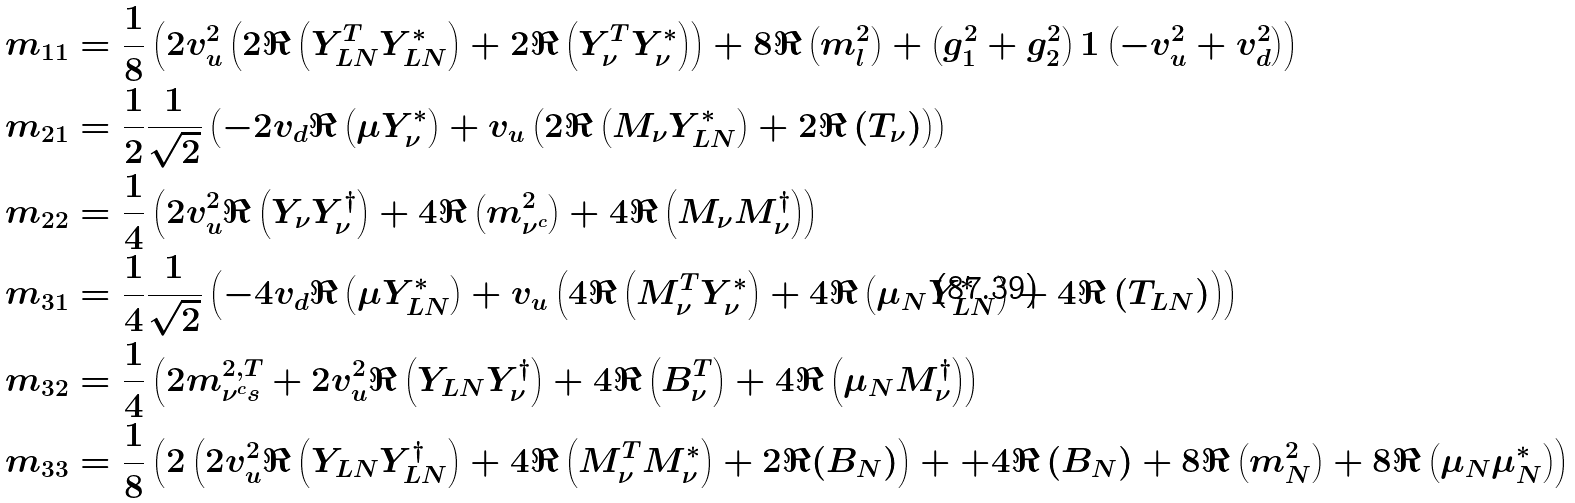<formula> <loc_0><loc_0><loc_500><loc_500>m _ { 1 1 } & = \frac { 1 } { 8 } \left ( 2 v _ { u } ^ { 2 } \left ( 2 { \Re \left ( { Y _ { L N } ^ { T } Y _ { L N } ^ { * } } \right ) } + 2 { \Re \left ( { Y _ { \nu } ^ { T } Y _ { \nu } ^ { * } } \right ) } \right ) + 8 { \Re \left ( m _ { l } ^ { 2 } \right ) } + \left ( g _ { 1 } ^ { 2 } + g _ { 2 } ^ { 2 } \right ) { 1 } \left ( - v _ { u } ^ { 2 } + v _ { d } ^ { 2 } \right ) \right ) \\ m _ { 2 1 } & = \frac { 1 } { 2 } \frac { 1 } { \sqrt { 2 } } \left ( - 2 v _ { d } { \Re \left ( \mu Y _ { \nu } ^ { * } \right ) } + v _ { u } \left ( 2 { \Re \left ( { M _ { \nu } Y _ { L N } ^ { * } } \right ) } + 2 { \Re \left ( T _ { \nu } \right ) } \right ) \right ) \\ m _ { 2 2 } & = \frac { 1 } { 4 } \left ( 2 v _ { u } ^ { 2 } { \Re \left ( { Y _ { \nu } Y _ { \nu } ^ { \dagger } } \right ) } + 4 { \Re \left ( m ^ { 2 } _ { \nu ^ { c } } \right ) } + 4 { \Re \left ( { M _ { \nu } M _ { \nu } ^ { \dagger } } \right ) } \right ) \\ m _ { 3 1 } & = \frac { 1 } { 4 } \frac { 1 } { \sqrt { 2 } } \left ( - 4 v _ { d } { \Re \left ( \mu Y _ { L N } ^ { * } \right ) } + v _ { u } \left ( 4 { \Re \left ( { M _ { \nu } ^ { T } Y _ { \nu } ^ { * } } \right ) } + 4 { \Re \left ( { \mu _ { N } Y _ { L N } ^ { * } } \right ) } + 4 { \Re \left ( T _ { L N } \right ) } \right ) \right ) \\ m _ { 3 2 } & = \frac { 1 } { 4 } \left ( 2 m _ { \nu ^ { c } s } ^ { 2 , T } + 2 v _ { u } ^ { 2 } { \Re \left ( { Y _ { L N } Y _ { \nu } ^ { \dagger } } \right ) } + 4 { \Re \left ( B _ { \nu } ^ { T } \right ) } + 4 { \Re \left ( { \mu _ { N } M _ { \nu } ^ { \dagger } } \right ) } \right ) \\ m _ { 3 3 } & = \frac { 1 } { 8 } \left ( 2 \left ( 2 v _ { u } ^ { 2 } { \Re \left ( { Y _ { L N } Y _ { L N } ^ { \dagger } } \right ) } + 4 { \Re \left ( { M _ { \nu } ^ { T } M _ { \nu } ^ { * } } \right ) } + 2 \Re ( B _ { N } ) \right ) + + 4 { \Re \left ( B _ { N } \right ) } + 8 { \Re \left ( m ^ { 2 } _ { N } \right ) } + 8 { \Re \left ( { \mu _ { N } \mu _ { N } ^ { * } } \right ) } \right )</formula> 